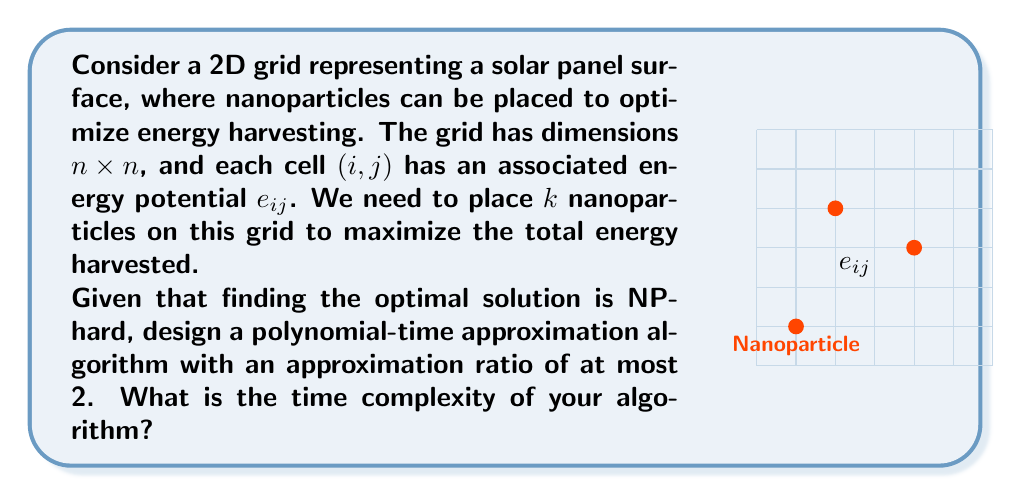Solve this math problem. To solve this problem, we can use a greedy approximation algorithm:

1) Initialize an empty set $S$ to store the selected positions.

2) While $|S| < k$:
   a) Find the cell $(i,j)$ with the maximum $e_{ij}$ that is not in $S$.
   b) Add $(i,j)$ to $S$.

3) Return $S$ as the solution.

This algorithm has an approximation ratio of at most 2 because:

1) Let OPT be the optimal solution and ALG be our algorithm's solution.
2) $ALG \geq \frac{1}{k} \sum_{(i,j) \in OPT} e_{ij}$
   (Our algorithm selects the $k$ highest values, so each is at least as large as the average of OPT)
3) $OPT \leq \sum_{(i,j) \in OPT} e_{ij} \leq k \cdot ALG$

Therefore, $OPT \leq 2 \cdot ALG$, giving us an approximation ratio of at most 2.

For the time complexity:
1) We need to scan the entire grid once to find the maximum $e_{ij}$, which takes $O(n^2)$ time.
2) We repeat this $k$ times.

Thus, the overall time complexity is $O(kn^2)$.

This algorithm is polynomial in the input size, as required for an approximation algorithm, and provides a solution within a factor of 2 of the optimal in polynomial time.
Answer: $O(kn^2)$ 